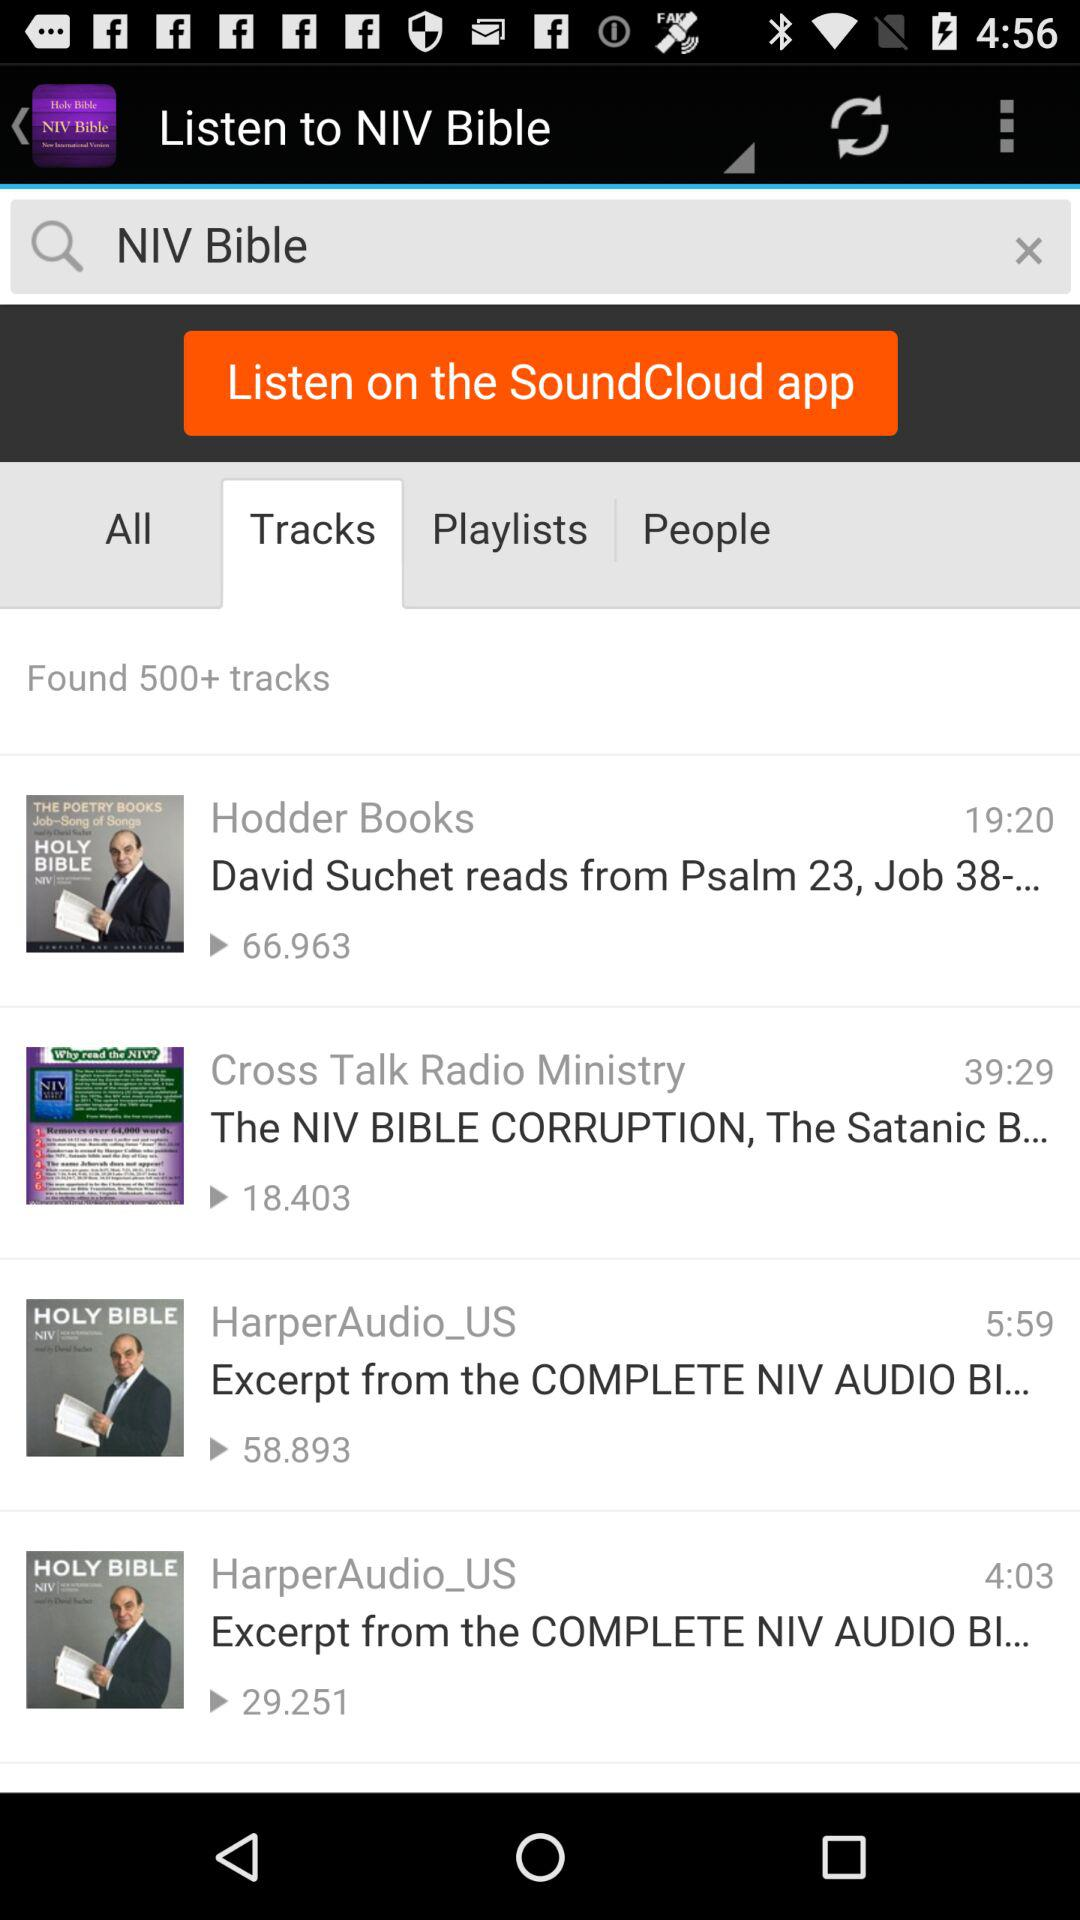What is the total length of the track by "HarperAudio_US"? The length of the tracks by "HarperAudio_US" are 5 minutes 59 seconds and 4 minutes 3 seconds. 